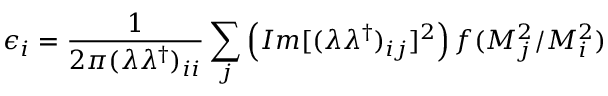<formula> <loc_0><loc_0><loc_500><loc_500>\epsilon _ { i } = \frac { 1 } { 2 \pi ( \lambda \lambda ^ { \dagger } ) _ { i i } } \sum _ { j } \left ( I m [ ( \lambda \lambda ^ { \dagger } ) _ { i j } ] ^ { 2 } \right ) f ( M _ { j } ^ { 2 } / M _ { i } ^ { 2 } )</formula> 